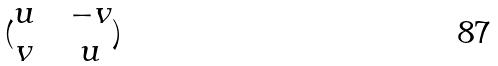<formula> <loc_0><loc_0><loc_500><loc_500>( \begin{matrix} u & & - v \\ v & & u \end{matrix} )</formula> 